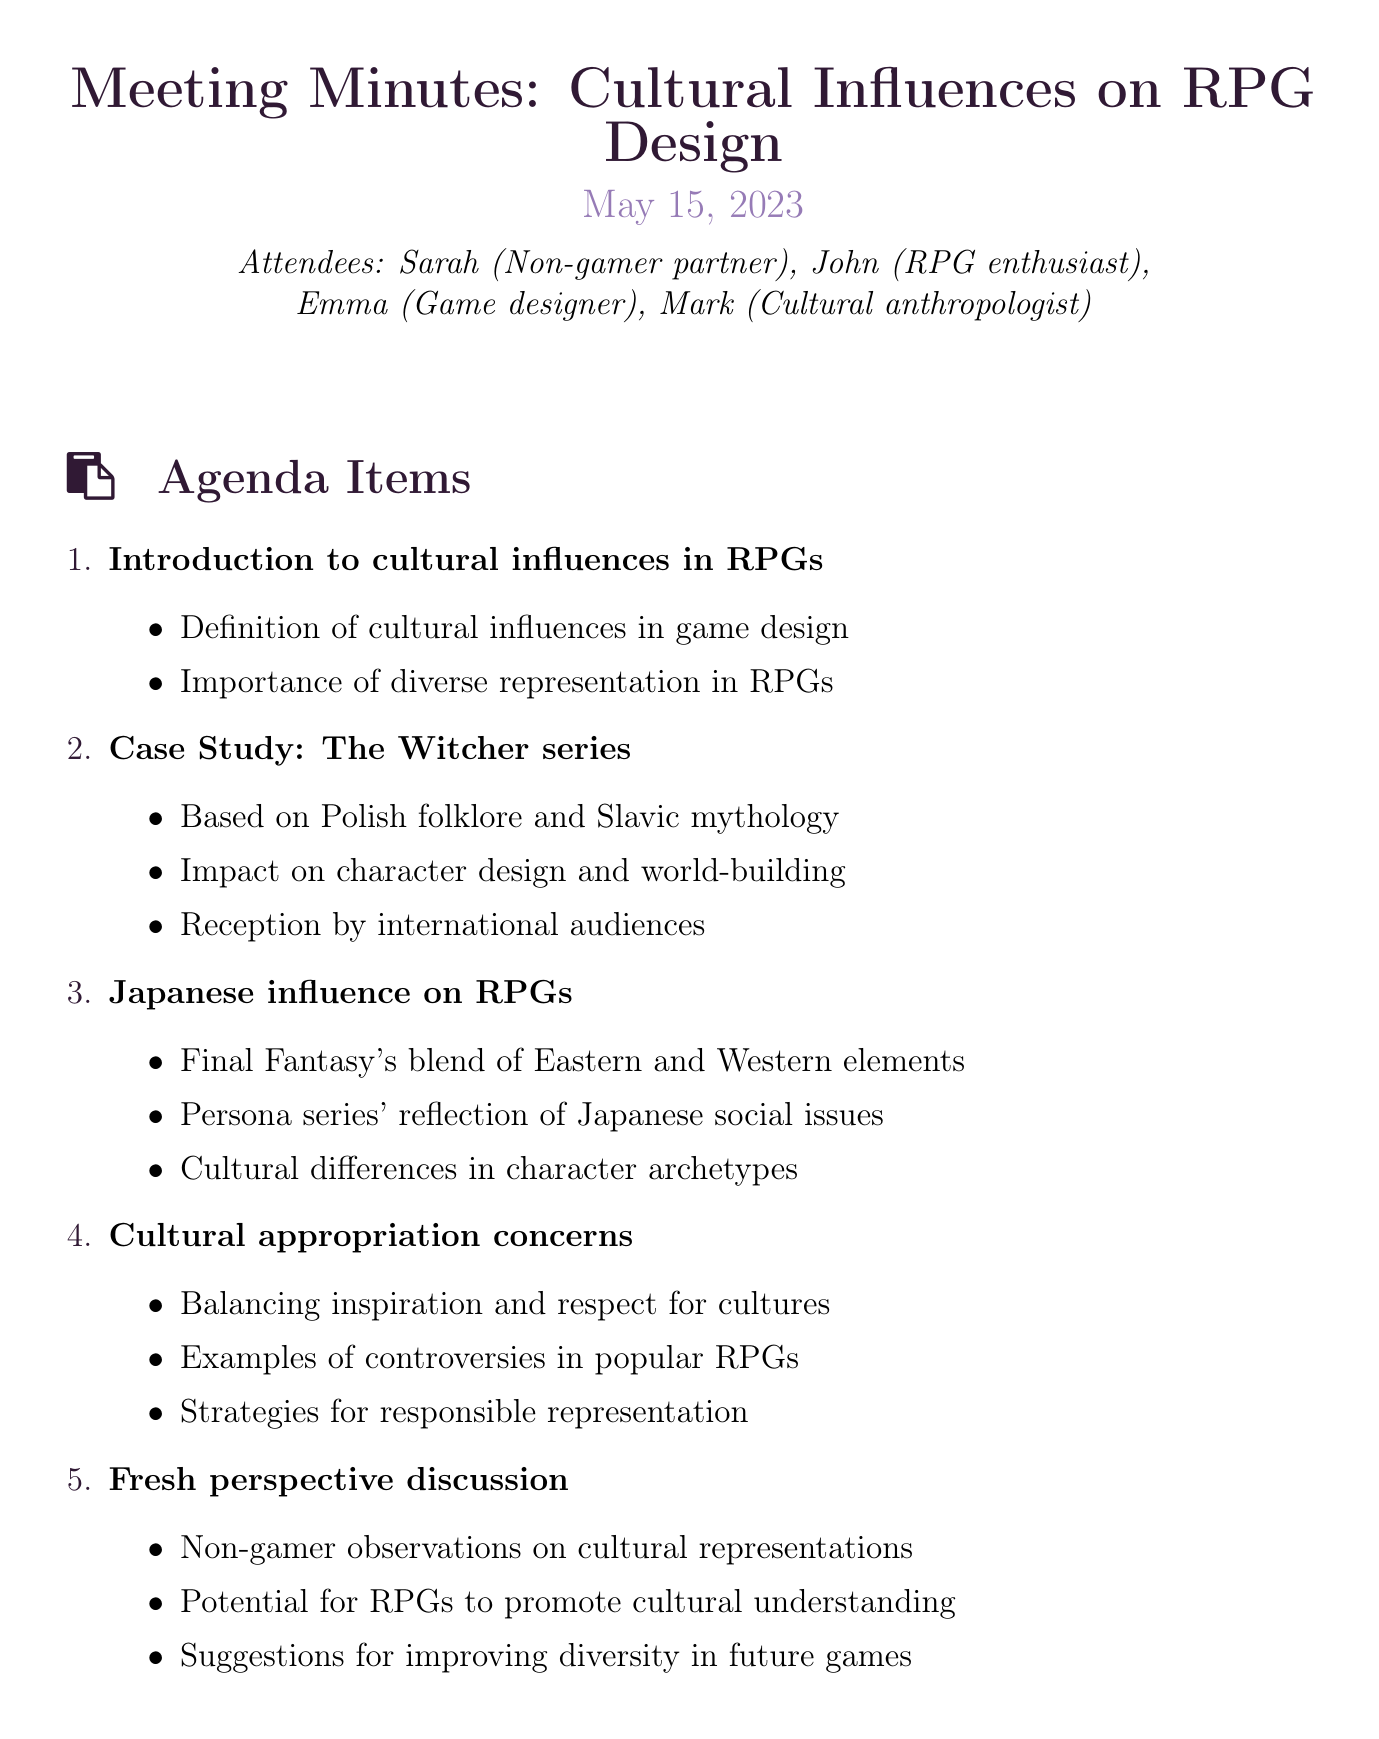What is the meeting title? The meeting title is explicitly stated at the beginning of the document.
Answer: Cultural Influences on RPG Design When was the meeting held? The date of the meeting is provided near the title.
Answer: May 15, 2023 Who is the cultural anthropologist in the meeting? The document lists the attendees, including their roles.
Answer: Mark Which agenda item discusses Japanese influence on RPGs? The agenda item related to Japanese influence is listed with a specific topic.
Answer: Japanese influence on RPGs What is one key point from the Case Study: The Witcher series? Each agenda item has specific key points outlining the discussion.
Answer: Based on Polish folklore and Slavic mythology What action item involves researching diverse RPG franchises? One of the action items explicitly mentions research related to diverse RPGs.
Answer: Research more diverse RPG franchises for future discussions How many agenda items are listed in total? The document enumerates the agenda items, which can be counted.
Answer: Five What is the next meeting date? The date for the next meeting is clearly stated at the end of the document.
Answer: June 12, 2023 